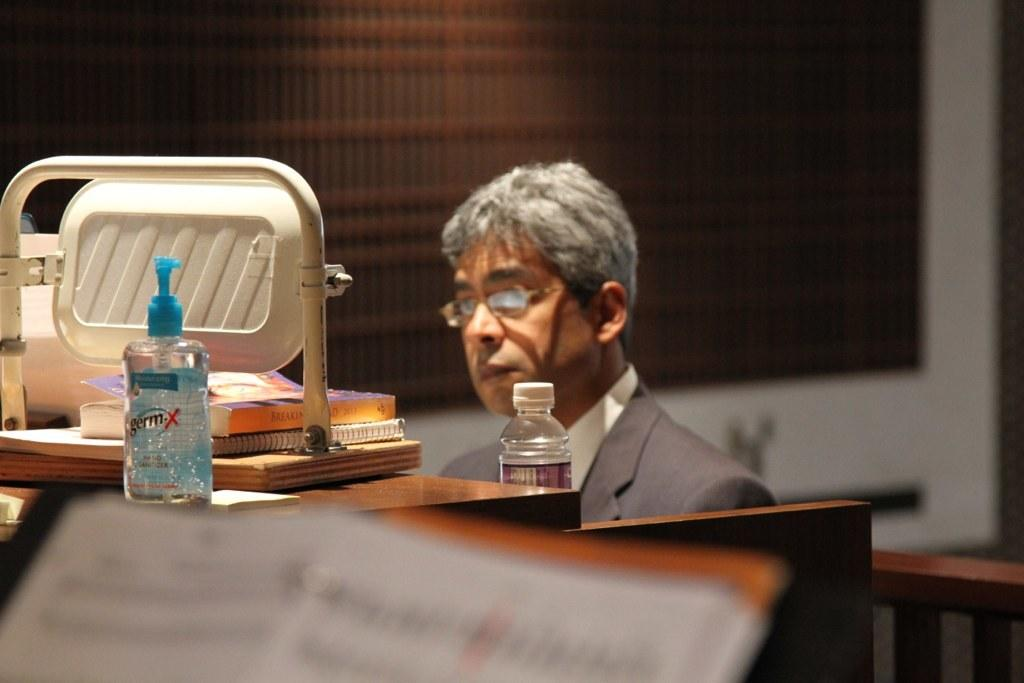What is the man in the image doing? There is a man sitting in the image. What is in front of the man? There is a bottle and books in front of the man. What can be seen in the background of the image? There is a wall in the background of the image. What advice does the horse give to the man in the image? There is no horse present in the image, so it is not possible to answer that question. 